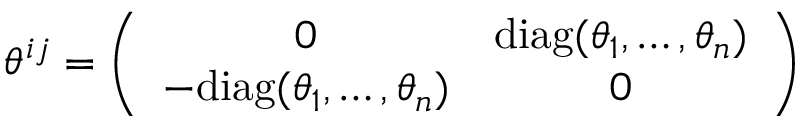Convert formula to latex. <formula><loc_0><loc_0><loc_500><loc_500>\theta ^ { i j } = \left ( \begin{array} { c c } { 0 } & { { d i a g ( \theta _ { 1 } , \dots , \theta _ { n } ) } } \\ { { - d i a g ( \theta _ { 1 } , \dots , \theta _ { n } ) } } & { 0 } \end{array} \right )</formula> 